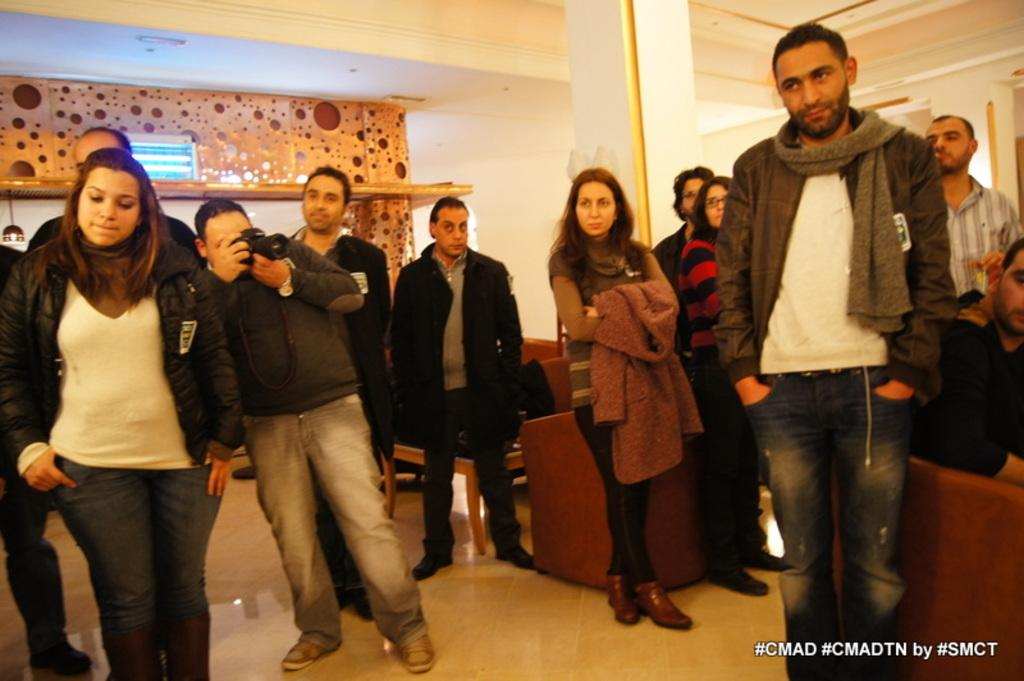<image>
Give a short and clear explanation of the subsequent image. a group of people with cmad at the bottom 